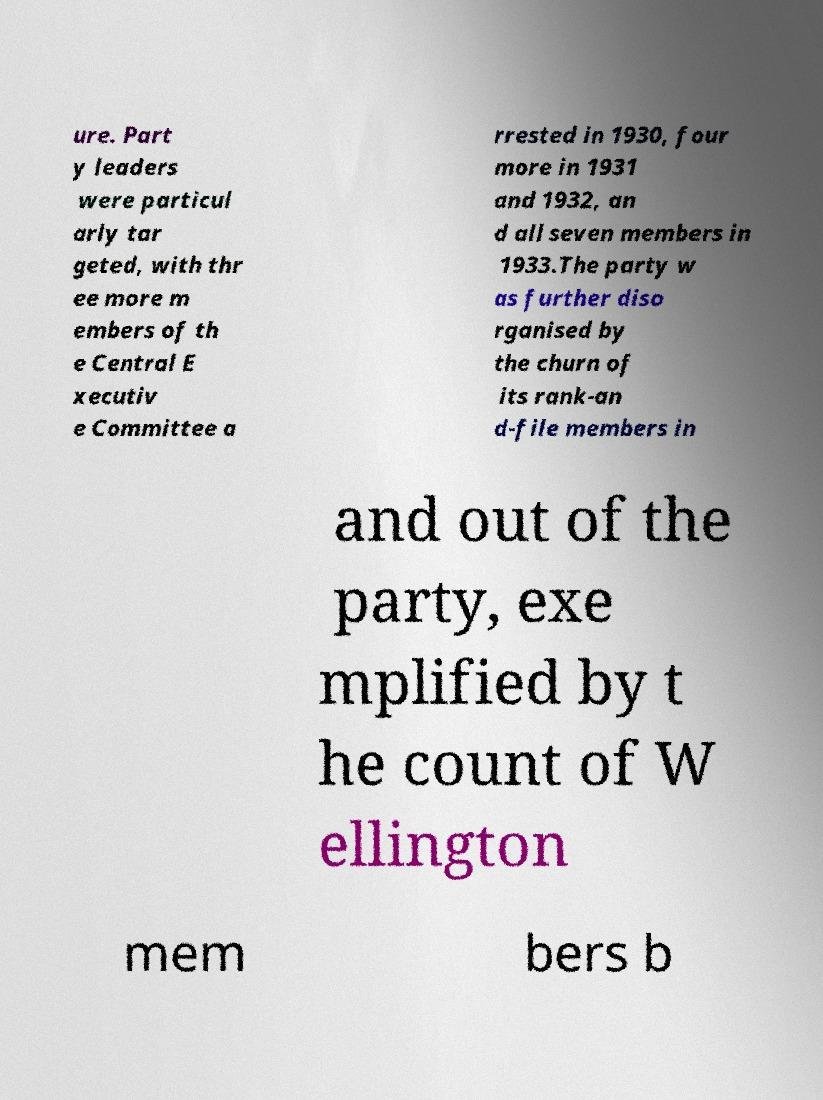Can you accurately transcribe the text from the provided image for me? ure. Part y leaders were particul arly tar geted, with thr ee more m embers of th e Central E xecutiv e Committee a rrested in 1930, four more in 1931 and 1932, an d all seven members in 1933.The party w as further diso rganised by the churn of its rank-an d-file members in and out of the party, exe mplified by t he count of W ellington mem bers b 